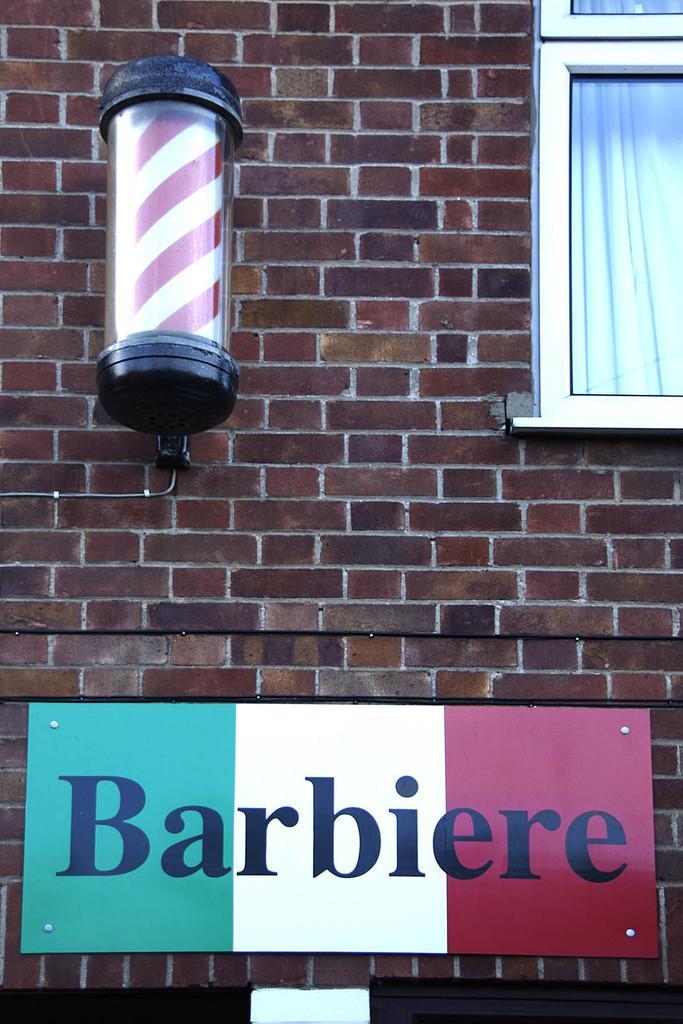Please provide a concise description of this image. This image is taken outdoors. In this image there is a wall with a window. On the left side of the image there is a wall. At the bottom of the image there is a board with a text on the wall. 